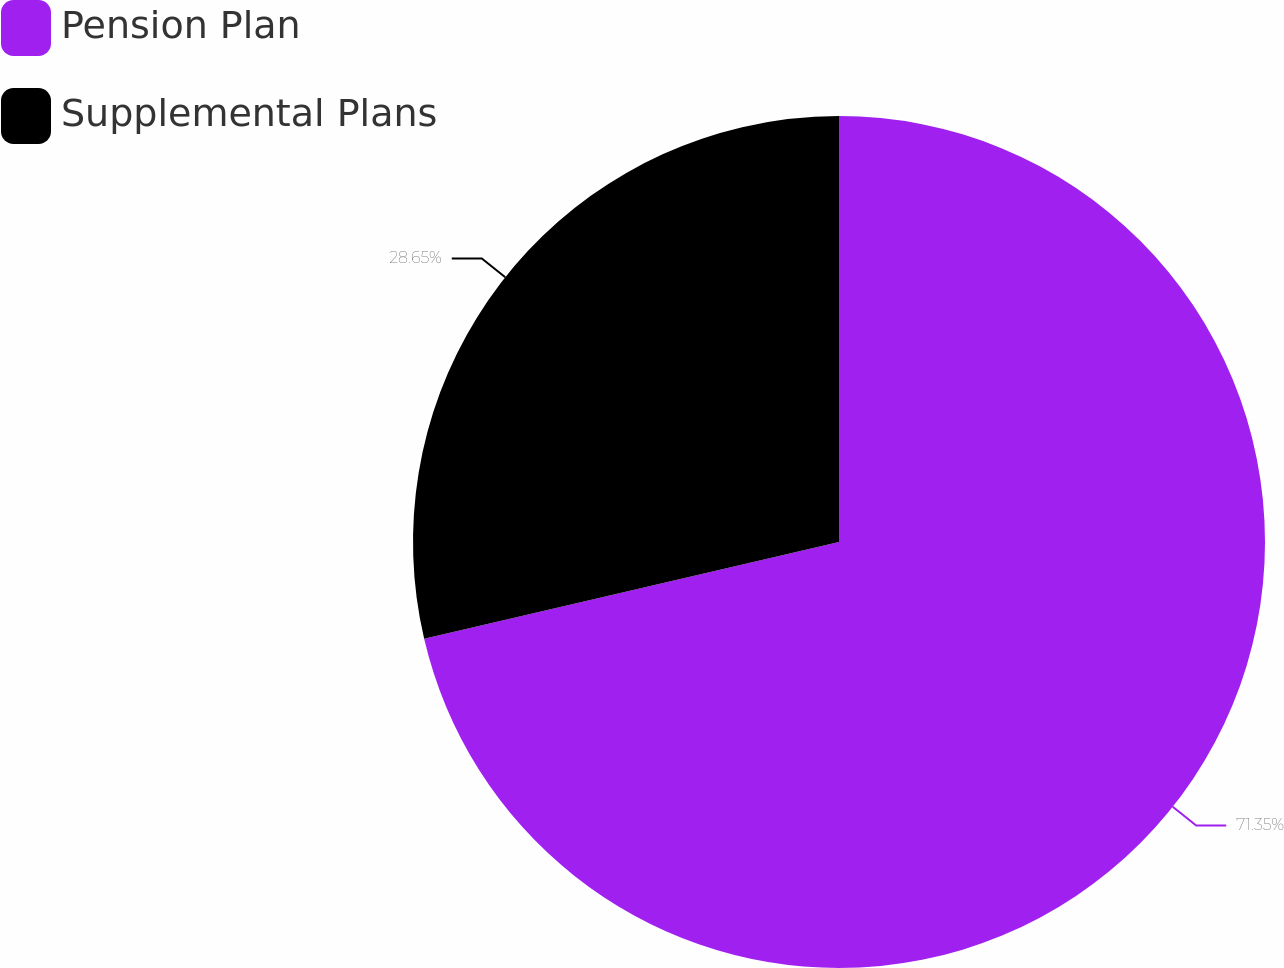Convert chart. <chart><loc_0><loc_0><loc_500><loc_500><pie_chart><fcel>Pension Plan<fcel>Supplemental Plans<nl><fcel>71.35%<fcel>28.65%<nl></chart> 